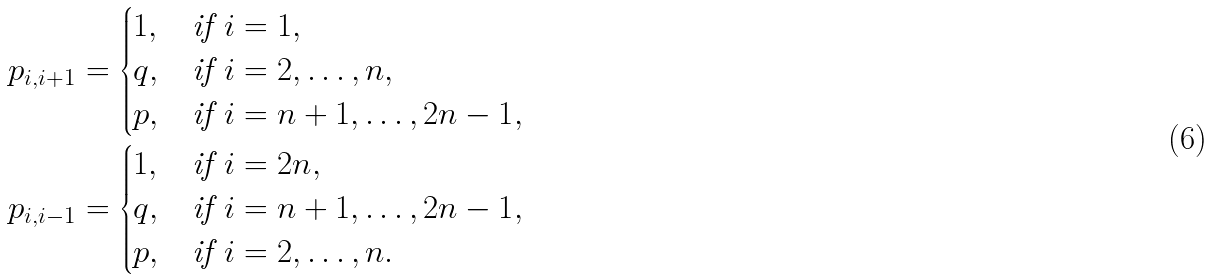Convert formula to latex. <formula><loc_0><loc_0><loc_500><loc_500>p _ { i , i + 1 } & = \begin{cases} 1 , & \text {if $i=1$} , \\ q , & \text {if $i=2,\dots ,n$} , \\ p , & \text {if $i=n+1,\dots ,2n-1$} , \end{cases} \\ p _ { i , i - 1 } & = \begin{cases} 1 , & \text {if $i=2n$} , \\ q , & \text {if $i=n+1,\dots ,2n-1$} , \\ p , & \text {if $i=2,\dots ,n$} . \end{cases}</formula> 